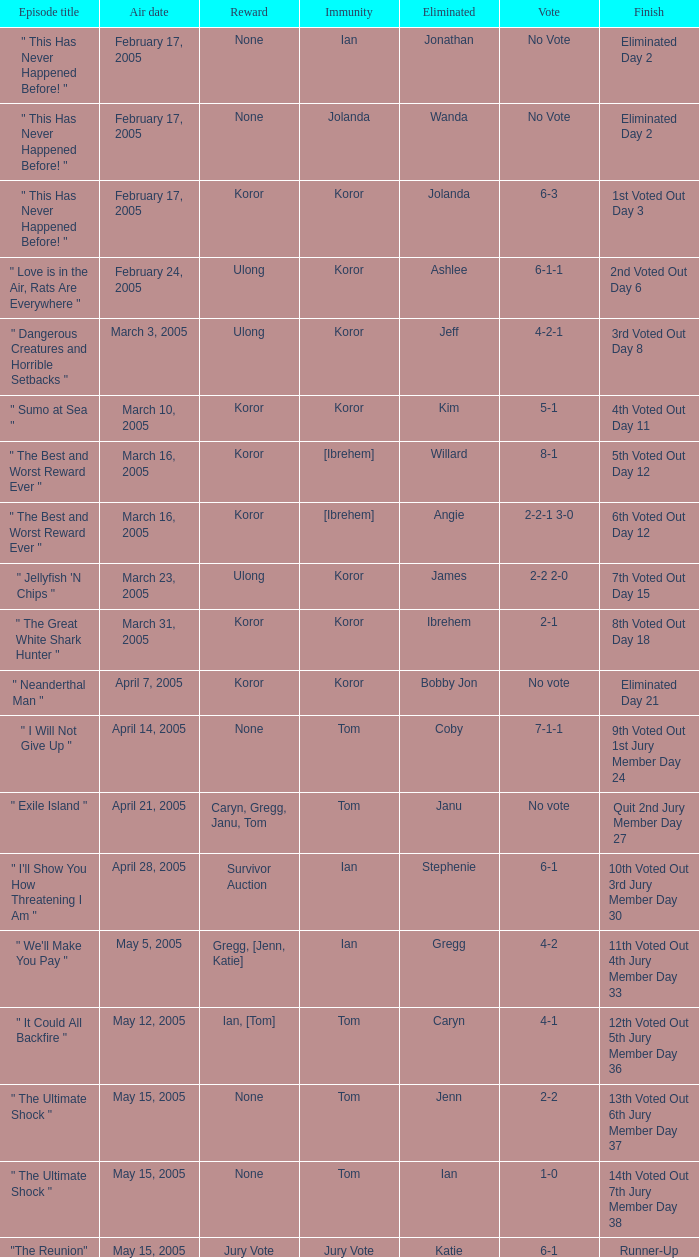What was the outcome on the episode where the conclusion was "10th voted out 3rd jury member day 30"? 6-1. 